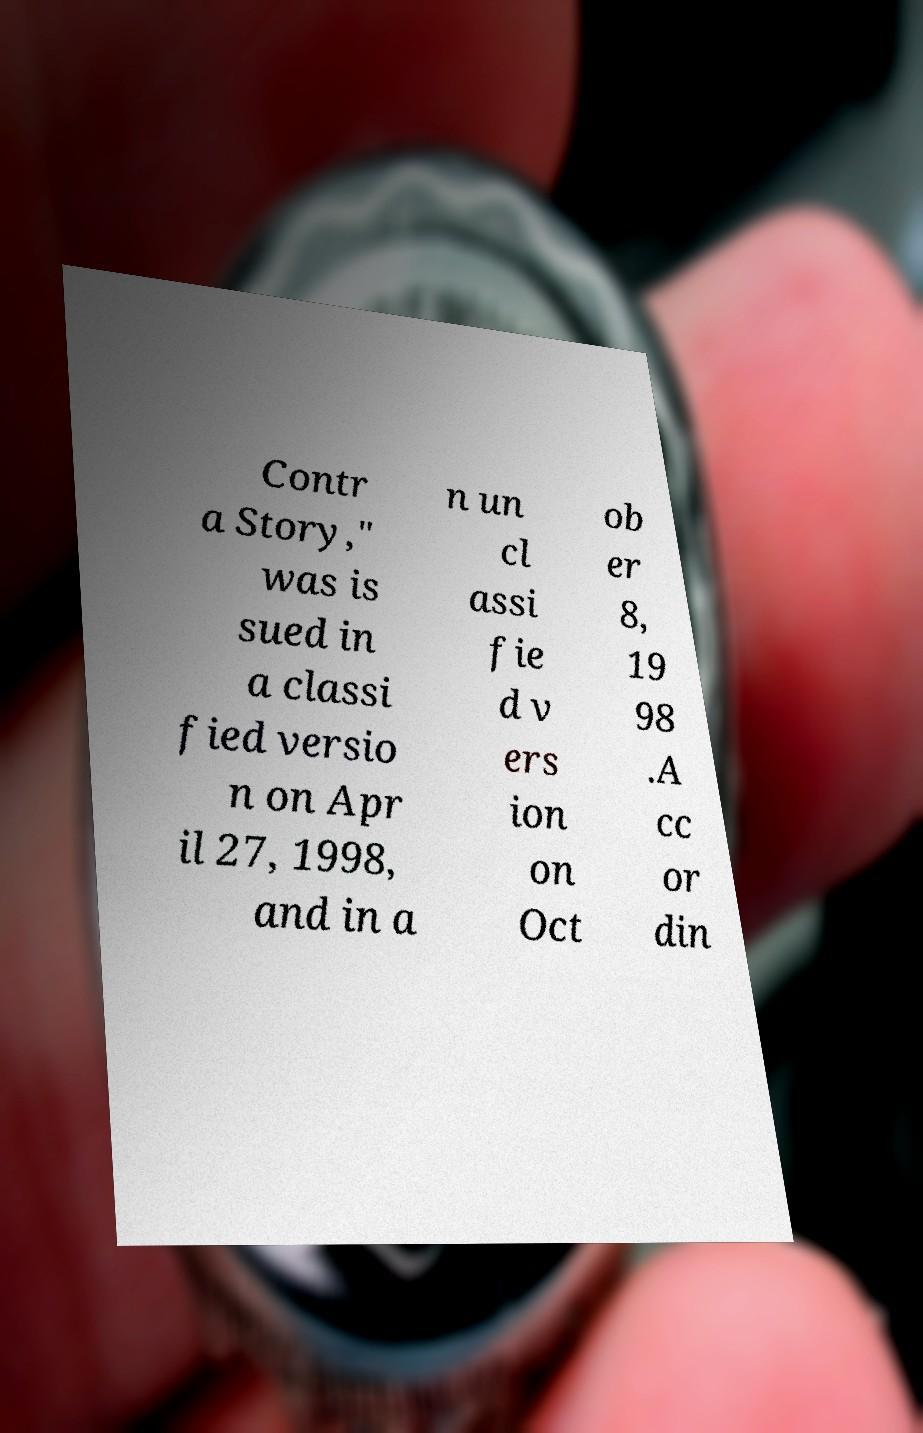Could you assist in decoding the text presented in this image and type it out clearly? Contr a Story," was is sued in a classi fied versio n on Apr il 27, 1998, and in a n un cl assi fie d v ers ion on Oct ob er 8, 19 98 .A cc or din 